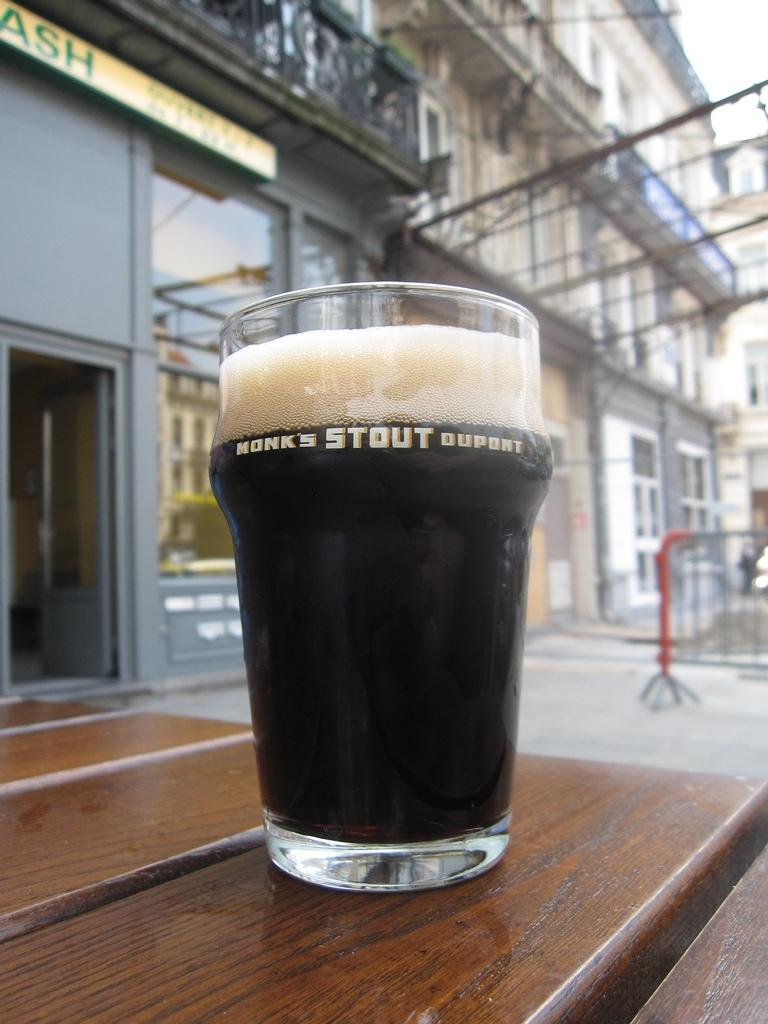<image>
Create a compact narrative representing the image presented. A fresh pour of Monk's Stout Dupont on a wooden table outside. 